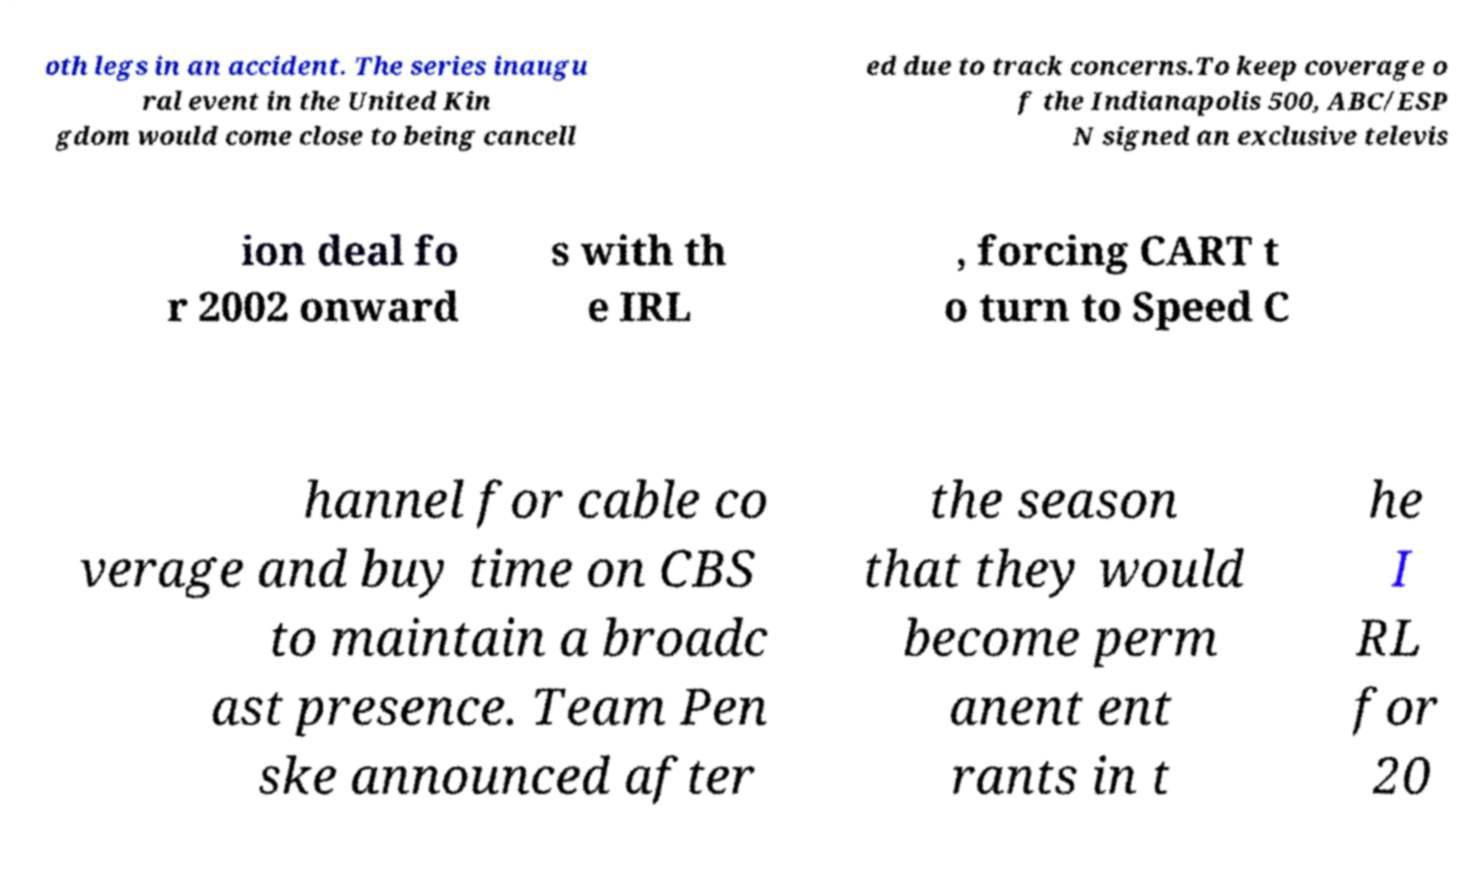There's text embedded in this image that I need extracted. Can you transcribe it verbatim? oth legs in an accident. The series inaugu ral event in the United Kin gdom would come close to being cancell ed due to track concerns.To keep coverage o f the Indianapolis 500, ABC/ESP N signed an exclusive televis ion deal fo r 2002 onward s with th e IRL , forcing CART t o turn to Speed C hannel for cable co verage and buy time on CBS to maintain a broadc ast presence. Team Pen ske announced after the season that they would become perm anent ent rants in t he I RL for 20 